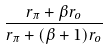<formula> <loc_0><loc_0><loc_500><loc_500>\frac { r _ { \pi } + \beta r _ { o } } { r _ { \pi } + ( \beta + 1 ) r _ { o } }</formula> 